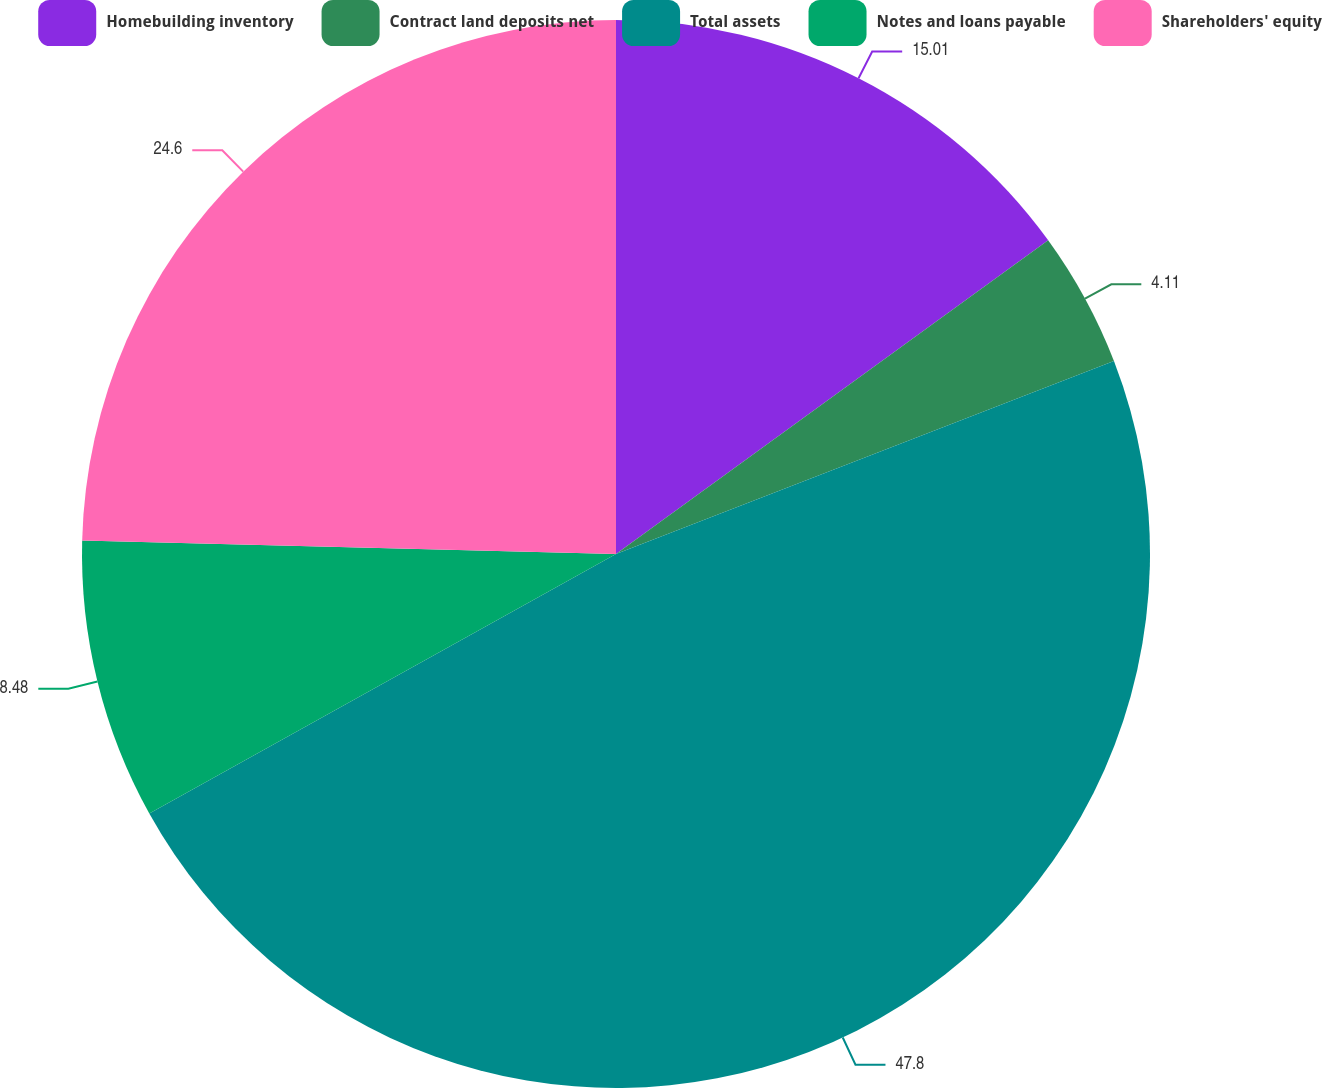Convert chart. <chart><loc_0><loc_0><loc_500><loc_500><pie_chart><fcel>Homebuilding inventory<fcel>Contract land deposits net<fcel>Total assets<fcel>Notes and loans payable<fcel>Shareholders' equity<nl><fcel>15.01%<fcel>4.11%<fcel>47.81%<fcel>8.48%<fcel>24.6%<nl></chart> 